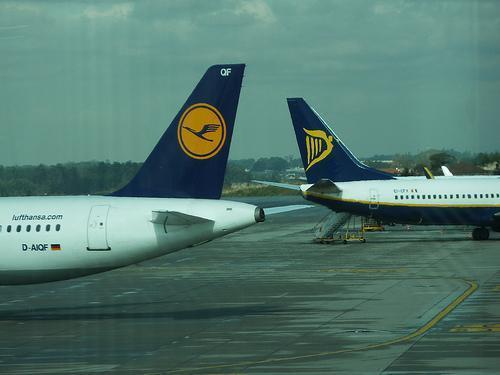How many planes are there?
Give a very brief answer. 2. How many of the planes in the image are purple?
Give a very brief answer. 0. 